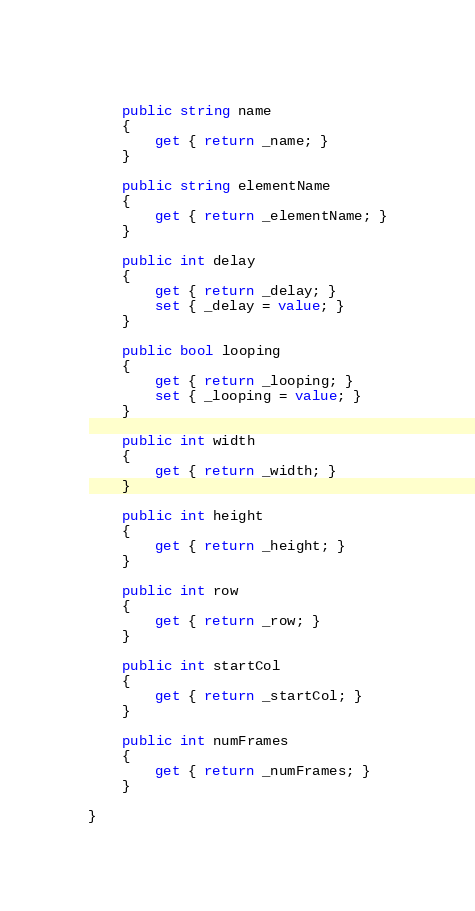Convert code to text. <code><loc_0><loc_0><loc_500><loc_500><_C#_>	
	public string name 
	{
		get { return _name; }
	}
	
	public string elementName 
	{
		get { return _elementName; }
	}
	
	public int delay 
	{
		get { return _delay; }
		set { _delay = value; }
	}
	
	public bool looping 
	{
		get { return _looping; }
		set { _looping = value; }
	}
	
	public int width 
	{
		get { return _width; }
	}
	
	public int height 
	{
		get { return _height; }
	}
	
	public int row 
	{
		get { return _row; }
	}
	
	public int startCol 
	{
		get { return _startCol; }
	}
	
	public int numFrames 
	{
		get { return _numFrames; }
	}
	
}</code> 